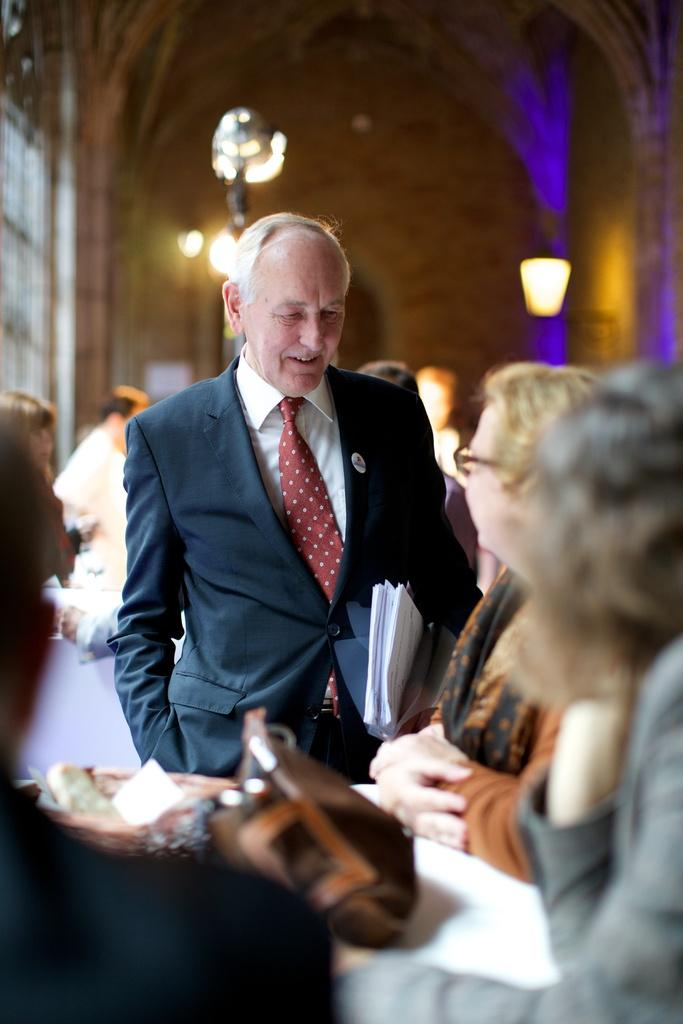What can be seen in the image in terms of people? There are people standing in the image. Can you describe the gender of the people in the image? There are women in the image. What object is on the table in the image? There is a handbag on the table. What is the man in the image holding? The man is holding papers in his hand. What type of illumination is present in the image? There are lights in the image. What else is on the table besides the handbag? There is a basket on the table. What type of rice is being cooked in the image? There is no rice present in the image. How many fingers does the woman in the image have? The number of fingers a person has cannot be determined from the image alone, as it is not visible in the image. 